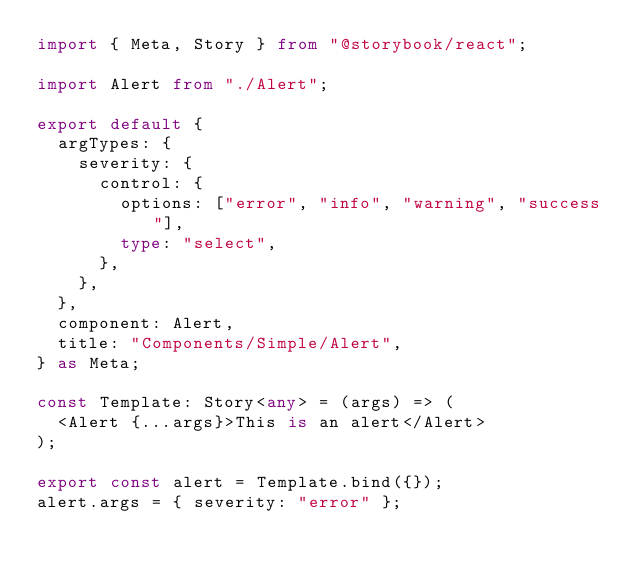<code> <loc_0><loc_0><loc_500><loc_500><_TypeScript_>import { Meta, Story } from "@storybook/react";

import Alert from "./Alert";

export default {
  argTypes: {
    severity: {
      control: {
        options: ["error", "info", "warning", "success"],
        type: "select",
      },
    },
  },
  component: Alert,
  title: "Components/Simple/Alert",
} as Meta;

const Template: Story<any> = (args) => (
  <Alert {...args}>This is an alert</Alert>
);

export const alert = Template.bind({});
alert.args = { severity: "error" };
</code> 